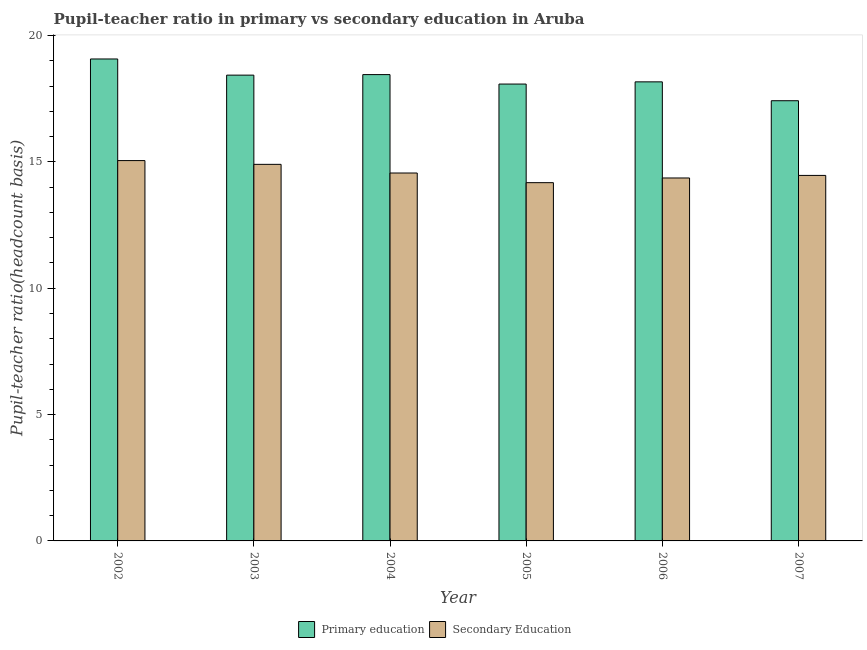How many different coloured bars are there?
Offer a very short reply. 2. Are the number of bars per tick equal to the number of legend labels?
Make the answer very short. Yes. How many bars are there on the 5th tick from the right?
Your response must be concise. 2. What is the label of the 5th group of bars from the left?
Keep it short and to the point. 2006. What is the pupil-teacher ratio in primary education in 2002?
Give a very brief answer. 19.07. Across all years, what is the maximum pupil-teacher ratio in primary education?
Offer a terse response. 19.07. Across all years, what is the minimum pupil teacher ratio on secondary education?
Offer a terse response. 14.18. In which year was the pupil teacher ratio on secondary education minimum?
Keep it short and to the point. 2005. What is the total pupil teacher ratio on secondary education in the graph?
Offer a terse response. 87.51. What is the difference between the pupil-teacher ratio in primary education in 2006 and that in 2007?
Keep it short and to the point. 0.75. What is the difference between the pupil-teacher ratio in primary education in 2005 and the pupil teacher ratio on secondary education in 2004?
Offer a very short reply. -0.37. What is the average pupil-teacher ratio in primary education per year?
Provide a succinct answer. 18.27. In the year 2006, what is the difference between the pupil teacher ratio on secondary education and pupil-teacher ratio in primary education?
Provide a succinct answer. 0. In how many years, is the pupil-teacher ratio in primary education greater than 7?
Keep it short and to the point. 6. What is the ratio of the pupil-teacher ratio in primary education in 2005 to that in 2007?
Make the answer very short. 1.04. What is the difference between the highest and the second highest pupil-teacher ratio in primary education?
Give a very brief answer. 0.62. What is the difference between the highest and the lowest pupil-teacher ratio in primary education?
Keep it short and to the point. 1.65. Is the sum of the pupil-teacher ratio in primary education in 2004 and 2007 greater than the maximum pupil teacher ratio on secondary education across all years?
Make the answer very short. Yes. What does the 1st bar from the left in 2002 represents?
Your answer should be compact. Primary education. What does the 1st bar from the right in 2003 represents?
Offer a terse response. Secondary Education. How many bars are there?
Give a very brief answer. 12. Are all the bars in the graph horizontal?
Provide a succinct answer. No. How many years are there in the graph?
Offer a terse response. 6. Are the values on the major ticks of Y-axis written in scientific E-notation?
Your answer should be very brief. No. Does the graph contain any zero values?
Keep it short and to the point. No. Does the graph contain grids?
Your answer should be compact. No. How many legend labels are there?
Ensure brevity in your answer.  2. How are the legend labels stacked?
Offer a terse response. Horizontal. What is the title of the graph?
Your response must be concise. Pupil-teacher ratio in primary vs secondary education in Aruba. What is the label or title of the Y-axis?
Your answer should be very brief. Pupil-teacher ratio(headcount basis). What is the Pupil-teacher ratio(headcount basis) in Primary education in 2002?
Your response must be concise. 19.07. What is the Pupil-teacher ratio(headcount basis) of Secondary Education in 2002?
Your response must be concise. 15.05. What is the Pupil-teacher ratio(headcount basis) in Primary education in 2003?
Your answer should be compact. 18.43. What is the Pupil-teacher ratio(headcount basis) of Secondary Education in 2003?
Provide a short and direct response. 14.9. What is the Pupil-teacher ratio(headcount basis) in Primary education in 2004?
Keep it short and to the point. 18.45. What is the Pupil-teacher ratio(headcount basis) of Secondary Education in 2004?
Your response must be concise. 14.56. What is the Pupil-teacher ratio(headcount basis) in Primary education in 2005?
Offer a very short reply. 18.08. What is the Pupil-teacher ratio(headcount basis) in Secondary Education in 2005?
Offer a very short reply. 14.18. What is the Pupil-teacher ratio(headcount basis) of Primary education in 2006?
Offer a terse response. 18.16. What is the Pupil-teacher ratio(headcount basis) in Secondary Education in 2006?
Your response must be concise. 14.36. What is the Pupil-teacher ratio(headcount basis) of Primary education in 2007?
Your answer should be compact. 17.42. What is the Pupil-teacher ratio(headcount basis) of Secondary Education in 2007?
Offer a very short reply. 14.46. Across all years, what is the maximum Pupil-teacher ratio(headcount basis) of Primary education?
Give a very brief answer. 19.07. Across all years, what is the maximum Pupil-teacher ratio(headcount basis) of Secondary Education?
Offer a terse response. 15.05. Across all years, what is the minimum Pupil-teacher ratio(headcount basis) of Primary education?
Give a very brief answer. 17.42. Across all years, what is the minimum Pupil-teacher ratio(headcount basis) in Secondary Education?
Give a very brief answer. 14.18. What is the total Pupil-teacher ratio(headcount basis) in Primary education in the graph?
Give a very brief answer. 109.61. What is the total Pupil-teacher ratio(headcount basis) in Secondary Education in the graph?
Offer a terse response. 87.51. What is the difference between the Pupil-teacher ratio(headcount basis) of Primary education in 2002 and that in 2003?
Your answer should be very brief. 0.64. What is the difference between the Pupil-teacher ratio(headcount basis) in Secondary Education in 2002 and that in 2003?
Offer a terse response. 0.15. What is the difference between the Pupil-teacher ratio(headcount basis) of Primary education in 2002 and that in 2004?
Your answer should be very brief. 0.62. What is the difference between the Pupil-teacher ratio(headcount basis) of Secondary Education in 2002 and that in 2004?
Provide a short and direct response. 0.49. What is the difference between the Pupil-teacher ratio(headcount basis) of Secondary Education in 2002 and that in 2005?
Your answer should be very brief. 0.87. What is the difference between the Pupil-teacher ratio(headcount basis) in Primary education in 2002 and that in 2006?
Offer a very short reply. 0.91. What is the difference between the Pupil-teacher ratio(headcount basis) of Secondary Education in 2002 and that in 2006?
Ensure brevity in your answer.  0.69. What is the difference between the Pupil-teacher ratio(headcount basis) of Primary education in 2002 and that in 2007?
Offer a terse response. 1.65. What is the difference between the Pupil-teacher ratio(headcount basis) in Secondary Education in 2002 and that in 2007?
Provide a succinct answer. 0.59. What is the difference between the Pupil-teacher ratio(headcount basis) of Primary education in 2003 and that in 2004?
Your answer should be compact. -0.02. What is the difference between the Pupil-teacher ratio(headcount basis) in Secondary Education in 2003 and that in 2004?
Your response must be concise. 0.34. What is the difference between the Pupil-teacher ratio(headcount basis) in Primary education in 2003 and that in 2005?
Offer a very short reply. 0.35. What is the difference between the Pupil-teacher ratio(headcount basis) of Secondary Education in 2003 and that in 2005?
Keep it short and to the point. 0.72. What is the difference between the Pupil-teacher ratio(headcount basis) of Primary education in 2003 and that in 2006?
Offer a terse response. 0.27. What is the difference between the Pupil-teacher ratio(headcount basis) in Secondary Education in 2003 and that in 2006?
Make the answer very short. 0.54. What is the difference between the Pupil-teacher ratio(headcount basis) of Primary education in 2003 and that in 2007?
Your answer should be compact. 1.01. What is the difference between the Pupil-teacher ratio(headcount basis) of Secondary Education in 2003 and that in 2007?
Keep it short and to the point. 0.44. What is the difference between the Pupil-teacher ratio(headcount basis) of Primary education in 2004 and that in 2005?
Your answer should be very brief. 0.37. What is the difference between the Pupil-teacher ratio(headcount basis) in Secondary Education in 2004 and that in 2005?
Offer a terse response. 0.38. What is the difference between the Pupil-teacher ratio(headcount basis) in Primary education in 2004 and that in 2006?
Make the answer very short. 0.29. What is the difference between the Pupil-teacher ratio(headcount basis) of Secondary Education in 2004 and that in 2006?
Your response must be concise. 0.2. What is the difference between the Pupil-teacher ratio(headcount basis) in Primary education in 2004 and that in 2007?
Offer a terse response. 1.03. What is the difference between the Pupil-teacher ratio(headcount basis) of Secondary Education in 2004 and that in 2007?
Offer a terse response. 0.1. What is the difference between the Pupil-teacher ratio(headcount basis) of Primary education in 2005 and that in 2006?
Offer a terse response. -0.09. What is the difference between the Pupil-teacher ratio(headcount basis) in Secondary Education in 2005 and that in 2006?
Your answer should be very brief. -0.19. What is the difference between the Pupil-teacher ratio(headcount basis) in Primary education in 2005 and that in 2007?
Offer a terse response. 0.66. What is the difference between the Pupil-teacher ratio(headcount basis) in Secondary Education in 2005 and that in 2007?
Provide a short and direct response. -0.29. What is the difference between the Pupil-teacher ratio(headcount basis) of Primary education in 2006 and that in 2007?
Give a very brief answer. 0.75. What is the difference between the Pupil-teacher ratio(headcount basis) of Secondary Education in 2006 and that in 2007?
Give a very brief answer. -0.1. What is the difference between the Pupil-teacher ratio(headcount basis) in Primary education in 2002 and the Pupil-teacher ratio(headcount basis) in Secondary Education in 2003?
Provide a short and direct response. 4.17. What is the difference between the Pupil-teacher ratio(headcount basis) of Primary education in 2002 and the Pupil-teacher ratio(headcount basis) of Secondary Education in 2004?
Ensure brevity in your answer.  4.51. What is the difference between the Pupil-teacher ratio(headcount basis) of Primary education in 2002 and the Pupil-teacher ratio(headcount basis) of Secondary Education in 2005?
Offer a terse response. 4.89. What is the difference between the Pupil-teacher ratio(headcount basis) in Primary education in 2002 and the Pupil-teacher ratio(headcount basis) in Secondary Education in 2006?
Give a very brief answer. 4.71. What is the difference between the Pupil-teacher ratio(headcount basis) of Primary education in 2002 and the Pupil-teacher ratio(headcount basis) of Secondary Education in 2007?
Offer a terse response. 4.61. What is the difference between the Pupil-teacher ratio(headcount basis) in Primary education in 2003 and the Pupil-teacher ratio(headcount basis) in Secondary Education in 2004?
Offer a very short reply. 3.87. What is the difference between the Pupil-teacher ratio(headcount basis) of Primary education in 2003 and the Pupil-teacher ratio(headcount basis) of Secondary Education in 2005?
Your answer should be compact. 4.25. What is the difference between the Pupil-teacher ratio(headcount basis) of Primary education in 2003 and the Pupil-teacher ratio(headcount basis) of Secondary Education in 2006?
Offer a very short reply. 4.07. What is the difference between the Pupil-teacher ratio(headcount basis) of Primary education in 2003 and the Pupil-teacher ratio(headcount basis) of Secondary Education in 2007?
Make the answer very short. 3.97. What is the difference between the Pupil-teacher ratio(headcount basis) in Primary education in 2004 and the Pupil-teacher ratio(headcount basis) in Secondary Education in 2005?
Keep it short and to the point. 4.28. What is the difference between the Pupil-teacher ratio(headcount basis) of Primary education in 2004 and the Pupil-teacher ratio(headcount basis) of Secondary Education in 2006?
Your response must be concise. 4.09. What is the difference between the Pupil-teacher ratio(headcount basis) in Primary education in 2004 and the Pupil-teacher ratio(headcount basis) in Secondary Education in 2007?
Provide a short and direct response. 3.99. What is the difference between the Pupil-teacher ratio(headcount basis) in Primary education in 2005 and the Pupil-teacher ratio(headcount basis) in Secondary Education in 2006?
Make the answer very short. 3.72. What is the difference between the Pupil-teacher ratio(headcount basis) of Primary education in 2005 and the Pupil-teacher ratio(headcount basis) of Secondary Education in 2007?
Your answer should be compact. 3.62. What is the difference between the Pupil-teacher ratio(headcount basis) of Primary education in 2006 and the Pupil-teacher ratio(headcount basis) of Secondary Education in 2007?
Give a very brief answer. 3.7. What is the average Pupil-teacher ratio(headcount basis) of Primary education per year?
Your answer should be very brief. 18.27. What is the average Pupil-teacher ratio(headcount basis) in Secondary Education per year?
Provide a succinct answer. 14.58. In the year 2002, what is the difference between the Pupil-teacher ratio(headcount basis) in Primary education and Pupil-teacher ratio(headcount basis) in Secondary Education?
Offer a very short reply. 4.02. In the year 2003, what is the difference between the Pupil-teacher ratio(headcount basis) of Primary education and Pupil-teacher ratio(headcount basis) of Secondary Education?
Make the answer very short. 3.53. In the year 2004, what is the difference between the Pupil-teacher ratio(headcount basis) of Primary education and Pupil-teacher ratio(headcount basis) of Secondary Education?
Ensure brevity in your answer.  3.89. In the year 2005, what is the difference between the Pupil-teacher ratio(headcount basis) of Primary education and Pupil-teacher ratio(headcount basis) of Secondary Education?
Your response must be concise. 3.9. In the year 2006, what is the difference between the Pupil-teacher ratio(headcount basis) of Primary education and Pupil-teacher ratio(headcount basis) of Secondary Education?
Offer a terse response. 3.8. In the year 2007, what is the difference between the Pupil-teacher ratio(headcount basis) in Primary education and Pupil-teacher ratio(headcount basis) in Secondary Education?
Ensure brevity in your answer.  2.96. What is the ratio of the Pupil-teacher ratio(headcount basis) of Primary education in 2002 to that in 2003?
Your answer should be compact. 1.03. What is the ratio of the Pupil-teacher ratio(headcount basis) in Secondary Education in 2002 to that in 2003?
Offer a terse response. 1.01. What is the ratio of the Pupil-teacher ratio(headcount basis) of Primary education in 2002 to that in 2004?
Your answer should be compact. 1.03. What is the ratio of the Pupil-teacher ratio(headcount basis) of Secondary Education in 2002 to that in 2004?
Provide a succinct answer. 1.03. What is the ratio of the Pupil-teacher ratio(headcount basis) in Primary education in 2002 to that in 2005?
Give a very brief answer. 1.05. What is the ratio of the Pupil-teacher ratio(headcount basis) of Secondary Education in 2002 to that in 2005?
Provide a succinct answer. 1.06. What is the ratio of the Pupil-teacher ratio(headcount basis) of Primary education in 2002 to that in 2006?
Provide a succinct answer. 1.05. What is the ratio of the Pupil-teacher ratio(headcount basis) of Secondary Education in 2002 to that in 2006?
Your answer should be very brief. 1.05. What is the ratio of the Pupil-teacher ratio(headcount basis) in Primary education in 2002 to that in 2007?
Make the answer very short. 1.09. What is the ratio of the Pupil-teacher ratio(headcount basis) in Secondary Education in 2002 to that in 2007?
Provide a succinct answer. 1.04. What is the ratio of the Pupil-teacher ratio(headcount basis) in Secondary Education in 2003 to that in 2004?
Ensure brevity in your answer.  1.02. What is the ratio of the Pupil-teacher ratio(headcount basis) in Primary education in 2003 to that in 2005?
Provide a short and direct response. 1.02. What is the ratio of the Pupil-teacher ratio(headcount basis) of Secondary Education in 2003 to that in 2005?
Ensure brevity in your answer.  1.05. What is the ratio of the Pupil-teacher ratio(headcount basis) in Primary education in 2003 to that in 2006?
Ensure brevity in your answer.  1.01. What is the ratio of the Pupil-teacher ratio(headcount basis) in Secondary Education in 2003 to that in 2006?
Offer a terse response. 1.04. What is the ratio of the Pupil-teacher ratio(headcount basis) in Primary education in 2003 to that in 2007?
Your response must be concise. 1.06. What is the ratio of the Pupil-teacher ratio(headcount basis) in Secondary Education in 2003 to that in 2007?
Offer a terse response. 1.03. What is the ratio of the Pupil-teacher ratio(headcount basis) of Primary education in 2004 to that in 2005?
Offer a terse response. 1.02. What is the ratio of the Pupil-teacher ratio(headcount basis) in Secondary Education in 2004 to that in 2005?
Give a very brief answer. 1.03. What is the ratio of the Pupil-teacher ratio(headcount basis) in Primary education in 2004 to that in 2006?
Your answer should be compact. 1.02. What is the ratio of the Pupil-teacher ratio(headcount basis) in Secondary Education in 2004 to that in 2006?
Provide a succinct answer. 1.01. What is the ratio of the Pupil-teacher ratio(headcount basis) in Primary education in 2004 to that in 2007?
Ensure brevity in your answer.  1.06. What is the ratio of the Pupil-teacher ratio(headcount basis) in Secondary Education in 2004 to that in 2007?
Your answer should be very brief. 1.01. What is the ratio of the Pupil-teacher ratio(headcount basis) in Secondary Education in 2005 to that in 2006?
Ensure brevity in your answer.  0.99. What is the ratio of the Pupil-teacher ratio(headcount basis) in Primary education in 2005 to that in 2007?
Ensure brevity in your answer.  1.04. What is the ratio of the Pupil-teacher ratio(headcount basis) in Secondary Education in 2005 to that in 2007?
Your response must be concise. 0.98. What is the ratio of the Pupil-teacher ratio(headcount basis) of Primary education in 2006 to that in 2007?
Provide a short and direct response. 1.04. What is the difference between the highest and the second highest Pupil-teacher ratio(headcount basis) in Primary education?
Give a very brief answer. 0.62. What is the difference between the highest and the second highest Pupil-teacher ratio(headcount basis) in Secondary Education?
Offer a terse response. 0.15. What is the difference between the highest and the lowest Pupil-teacher ratio(headcount basis) in Primary education?
Keep it short and to the point. 1.65. What is the difference between the highest and the lowest Pupil-teacher ratio(headcount basis) in Secondary Education?
Your response must be concise. 0.87. 